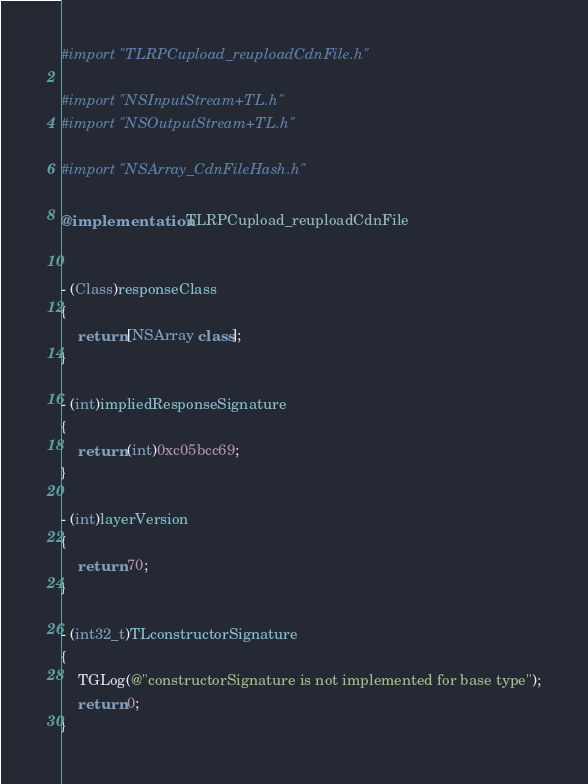Convert code to text. <code><loc_0><loc_0><loc_500><loc_500><_ObjectiveC_>#import "TLRPCupload_reuploadCdnFile.h"

#import "NSInputStream+TL.h"
#import "NSOutputStream+TL.h"

#import "NSArray_CdnFileHash.h"

@implementation TLRPCupload_reuploadCdnFile


- (Class)responseClass
{
    return [NSArray class];
}

- (int)impliedResponseSignature
{
    return (int)0xc05bcc69;
}

- (int)layerVersion
{
    return 70;
}

- (int32_t)TLconstructorSignature
{
    TGLog(@"constructorSignature is not implemented for base type");
    return 0;
}
</code> 